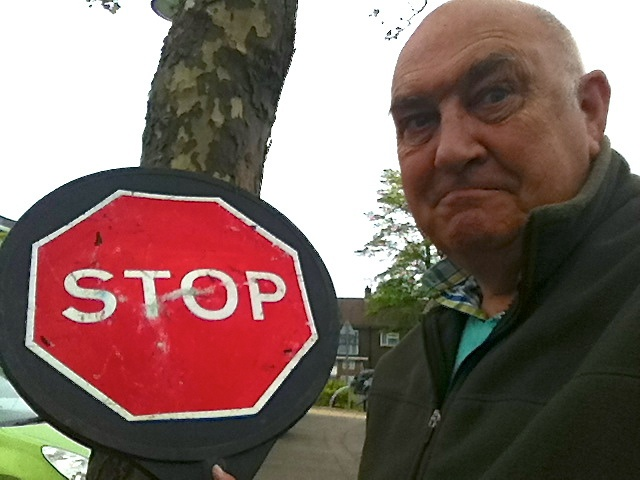Describe the objects in this image and their specific colors. I can see people in white, black, maroon, gray, and brown tones and stop sign in white, brown, and beige tones in this image. 